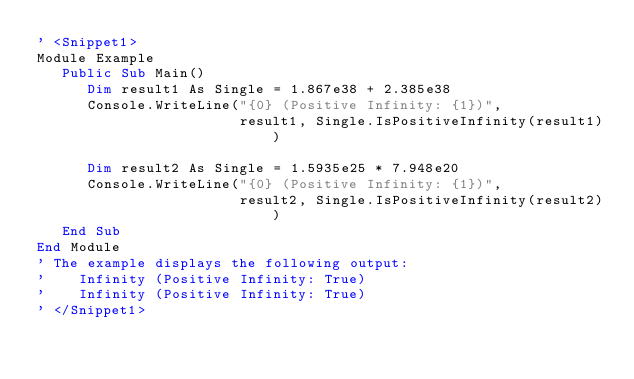Convert code to text. <code><loc_0><loc_0><loc_500><loc_500><_VisualBasic_>' <Snippet1>
Module Example
   Public Sub Main()
      Dim result1 As Single = 1.867e38 + 2.385e38
      Console.WriteLine("{0} (Positive Infinity: {1})", 
                        result1, Single.IsPositiveInfinity(result1))
      
      Dim result2 As Single = 1.5935e25 * 7.948e20
      Console.WriteLine("{0} (Positive Infinity: {1})", 
                        result2, Single.IsPositiveInfinity(result2))
   End Sub
End Module
' The example displays the following output:
'    Infinity (Positive Infinity: True)
'    Infinity (Positive Infinity: True)
' </Snippet1>

</code> 